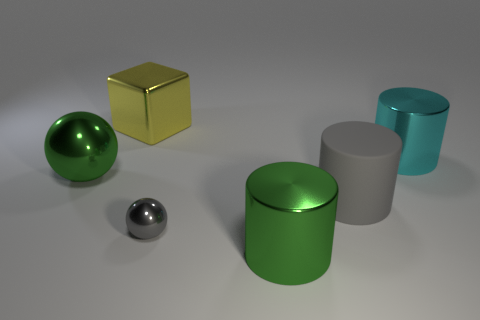Subtract all green cylinders. How many cylinders are left? 2 Add 1 cyan shiny things. How many objects exist? 7 Subtract all cubes. How many objects are left? 5 Subtract all green balls. Subtract all red cylinders. How many balls are left? 1 Subtract 0 red cubes. How many objects are left? 6 Subtract all small cyan matte things. Subtract all yellow things. How many objects are left? 5 Add 4 cyan metallic things. How many cyan metallic things are left? 5 Add 4 cyan cylinders. How many cyan cylinders exist? 5 